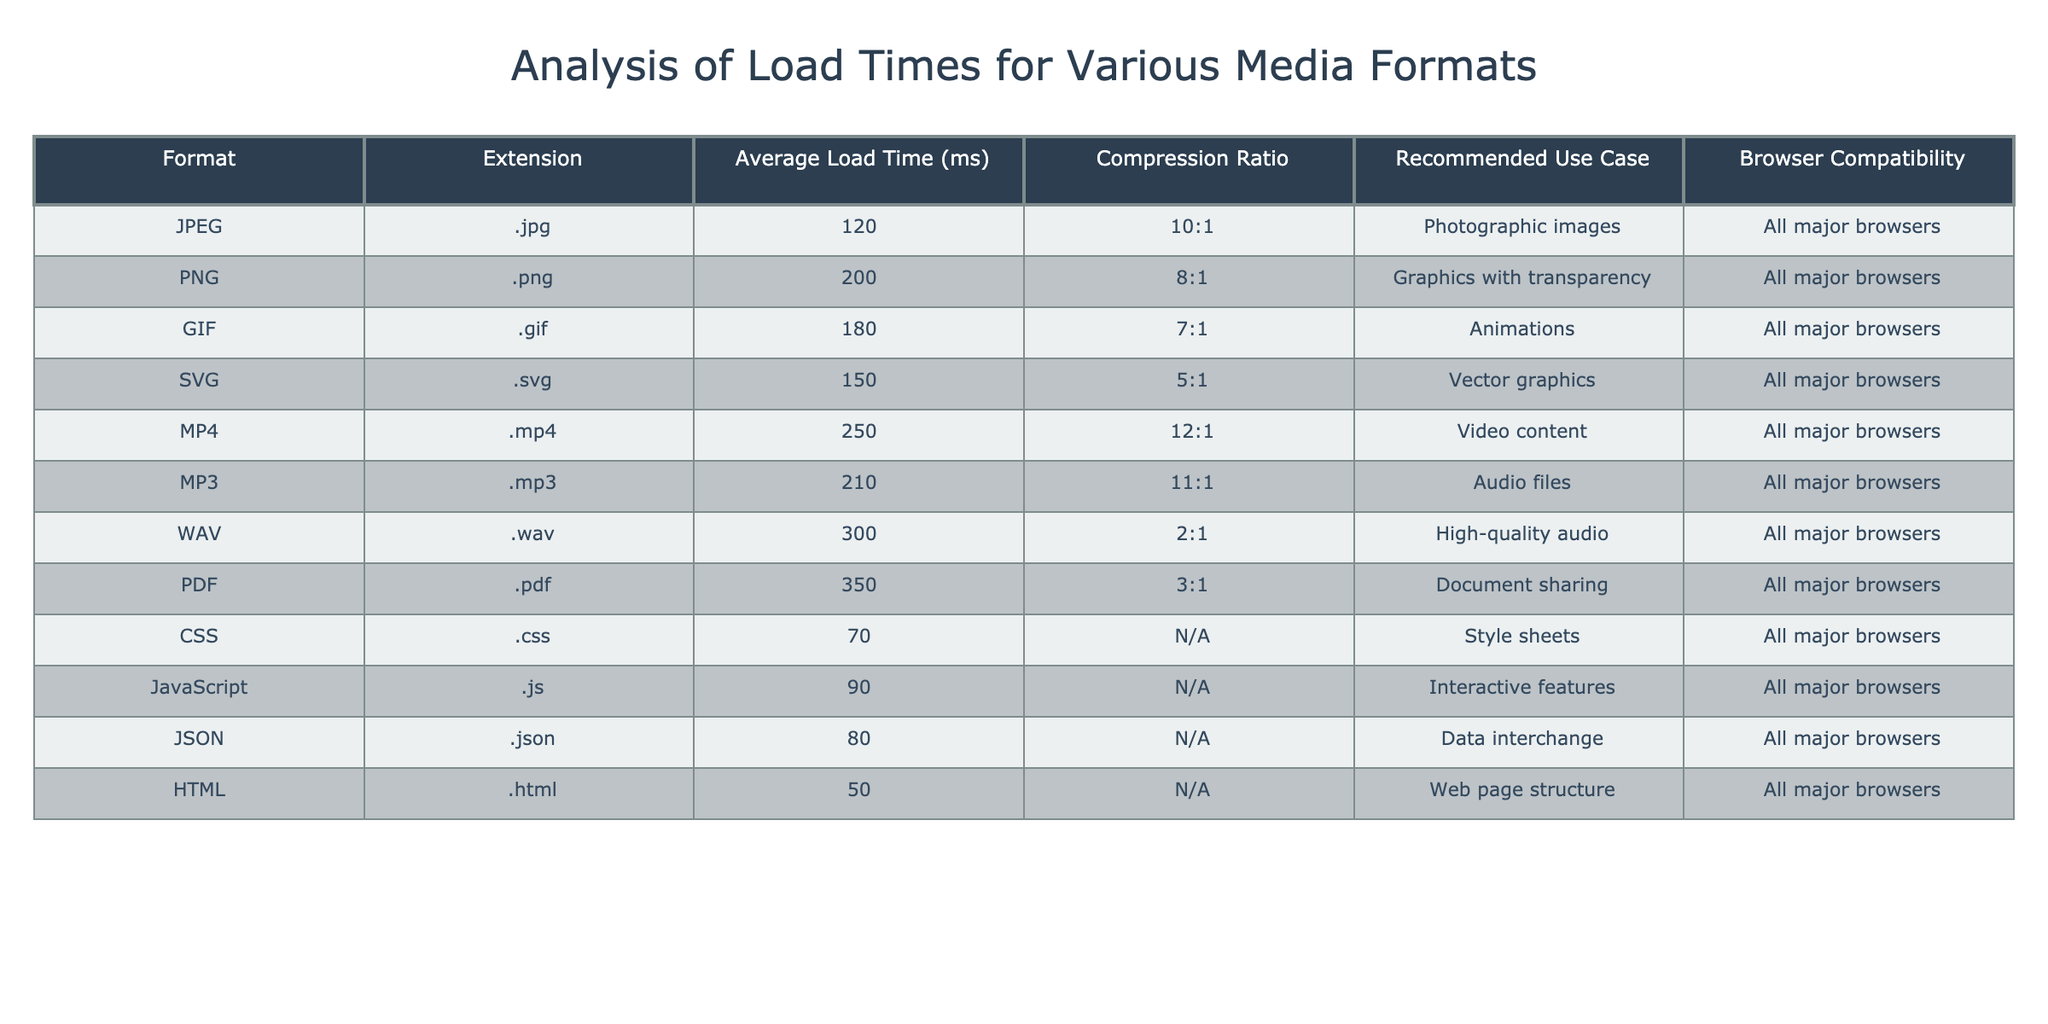What is the average load time for JPEG and PNG formats? The average load time for JPEG is 120 ms, and for PNG it is 200 ms. To find the average, we add the two values: 120 + 200 = 320 ms, and then we divide by 2, resulting in 320 / 2 = 160 ms.
Answer: 160 ms Which media format has the highest average load time? By comparing all the average load times in the table, WAV has the highest load time at 300 ms.
Answer: WAV Is the compression ratio for MP4 higher than that of WAV? The compression ratio for MP4 is 12:1, while for WAV it is 2:1. Since 12:1 is greater than 2:1, MP4 does indeed have a higher compression ratio than WAV.
Answer: Yes What is the total average load time for CSS and JavaScript formats? The average load time for CSS is 70 ms, and for JavaScript it is 90 ms. Adding these gives 70 + 90 = 160 ms, which is the total average load time for these two formats.
Answer: 160 ms Are all the listed media formats compatible with all major browsers? The table states that all listed formats are compatible with all major browsers, confirming a yes answer to the question.
Answer: Yes What is the average load time of all formats listed in the table? To calculate the average load time of all formats, we must first sum the individual average load times: 120 + 200 + 180 + 150 + 250 + 210 + 300 + 350 + 70 + 90 + 80 + 50 = 2,030 ms. Since there are 12 formats, we divide by 12: 2030 / 12 = approximately 169.17 ms.
Answer: 169.17 ms What media format has the best compression ratio? The best compression ratio is for JPEG format, with a compression ratio of 10:1. Comparing all ratios shown, no other format exceeds this value.
Answer: JPEG Is GIF recommended for photographic images? The table specifies that GIF is used for animations, not photographic images, which makes this statement false.
Answer: No 